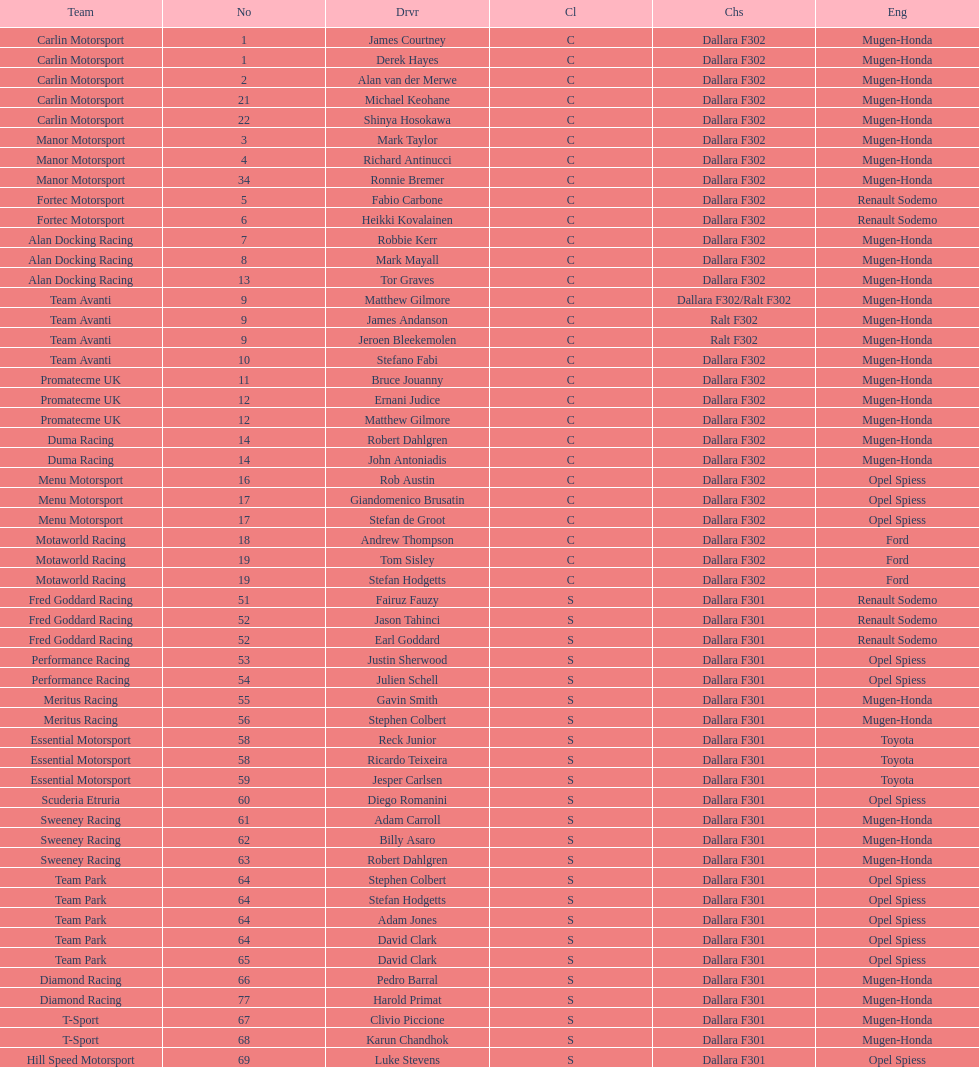Could you parse the entire table as a dict? {'header': ['Team', 'No', 'Drvr', 'Cl', 'Chs', 'Eng'], 'rows': [['Carlin Motorsport', '1', 'James Courtney', 'C', 'Dallara F302', 'Mugen-Honda'], ['Carlin Motorsport', '1', 'Derek Hayes', 'C', 'Dallara F302', 'Mugen-Honda'], ['Carlin Motorsport', '2', 'Alan van der Merwe', 'C', 'Dallara F302', 'Mugen-Honda'], ['Carlin Motorsport', '21', 'Michael Keohane', 'C', 'Dallara F302', 'Mugen-Honda'], ['Carlin Motorsport', '22', 'Shinya Hosokawa', 'C', 'Dallara F302', 'Mugen-Honda'], ['Manor Motorsport', '3', 'Mark Taylor', 'C', 'Dallara F302', 'Mugen-Honda'], ['Manor Motorsport', '4', 'Richard Antinucci', 'C', 'Dallara F302', 'Mugen-Honda'], ['Manor Motorsport', '34', 'Ronnie Bremer', 'C', 'Dallara F302', 'Mugen-Honda'], ['Fortec Motorsport', '5', 'Fabio Carbone', 'C', 'Dallara F302', 'Renault Sodemo'], ['Fortec Motorsport', '6', 'Heikki Kovalainen', 'C', 'Dallara F302', 'Renault Sodemo'], ['Alan Docking Racing', '7', 'Robbie Kerr', 'C', 'Dallara F302', 'Mugen-Honda'], ['Alan Docking Racing', '8', 'Mark Mayall', 'C', 'Dallara F302', 'Mugen-Honda'], ['Alan Docking Racing', '13', 'Tor Graves', 'C', 'Dallara F302', 'Mugen-Honda'], ['Team Avanti', '9', 'Matthew Gilmore', 'C', 'Dallara F302/Ralt F302', 'Mugen-Honda'], ['Team Avanti', '9', 'James Andanson', 'C', 'Ralt F302', 'Mugen-Honda'], ['Team Avanti', '9', 'Jeroen Bleekemolen', 'C', 'Ralt F302', 'Mugen-Honda'], ['Team Avanti', '10', 'Stefano Fabi', 'C', 'Dallara F302', 'Mugen-Honda'], ['Promatecme UK', '11', 'Bruce Jouanny', 'C', 'Dallara F302', 'Mugen-Honda'], ['Promatecme UK', '12', 'Ernani Judice', 'C', 'Dallara F302', 'Mugen-Honda'], ['Promatecme UK', '12', 'Matthew Gilmore', 'C', 'Dallara F302', 'Mugen-Honda'], ['Duma Racing', '14', 'Robert Dahlgren', 'C', 'Dallara F302', 'Mugen-Honda'], ['Duma Racing', '14', 'John Antoniadis', 'C', 'Dallara F302', 'Mugen-Honda'], ['Menu Motorsport', '16', 'Rob Austin', 'C', 'Dallara F302', 'Opel Spiess'], ['Menu Motorsport', '17', 'Giandomenico Brusatin', 'C', 'Dallara F302', 'Opel Spiess'], ['Menu Motorsport', '17', 'Stefan de Groot', 'C', 'Dallara F302', 'Opel Spiess'], ['Motaworld Racing', '18', 'Andrew Thompson', 'C', 'Dallara F302', 'Ford'], ['Motaworld Racing', '19', 'Tom Sisley', 'C', 'Dallara F302', 'Ford'], ['Motaworld Racing', '19', 'Stefan Hodgetts', 'C', 'Dallara F302', 'Ford'], ['Fred Goddard Racing', '51', 'Fairuz Fauzy', 'S', 'Dallara F301', 'Renault Sodemo'], ['Fred Goddard Racing', '52', 'Jason Tahinci', 'S', 'Dallara F301', 'Renault Sodemo'], ['Fred Goddard Racing', '52', 'Earl Goddard', 'S', 'Dallara F301', 'Renault Sodemo'], ['Performance Racing', '53', 'Justin Sherwood', 'S', 'Dallara F301', 'Opel Spiess'], ['Performance Racing', '54', 'Julien Schell', 'S', 'Dallara F301', 'Opel Spiess'], ['Meritus Racing', '55', 'Gavin Smith', 'S', 'Dallara F301', 'Mugen-Honda'], ['Meritus Racing', '56', 'Stephen Colbert', 'S', 'Dallara F301', 'Mugen-Honda'], ['Essential Motorsport', '58', 'Reck Junior', 'S', 'Dallara F301', 'Toyota'], ['Essential Motorsport', '58', 'Ricardo Teixeira', 'S', 'Dallara F301', 'Toyota'], ['Essential Motorsport', '59', 'Jesper Carlsen', 'S', 'Dallara F301', 'Toyota'], ['Scuderia Etruria', '60', 'Diego Romanini', 'S', 'Dallara F301', 'Opel Spiess'], ['Sweeney Racing', '61', 'Adam Carroll', 'S', 'Dallara F301', 'Mugen-Honda'], ['Sweeney Racing', '62', 'Billy Asaro', 'S', 'Dallara F301', 'Mugen-Honda'], ['Sweeney Racing', '63', 'Robert Dahlgren', 'S', 'Dallara F301', 'Mugen-Honda'], ['Team Park', '64', 'Stephen Colbert', 'S', 'Dallara F301', 'Opel Spiess'], ['Team Park', '64', 'Stefan Hodgetts', 'S', 'Dallara F301', 'Opel Spiess'], ['Team Park', '64', 'Adam Jones', 'S', 'Dallara F301', 'Opel Spiess'], ['Team Park', '64', 'David Clark', 'S', 'Dallara F301', 'Opel Spiess'], ['Team Park', '65', 'David Clark', 'S', 'Dallara F301', 'Opel Spiess'], ['Diamond Racing', '66', 'Pedro Barral', 'S', 'Dallara F301', 'Mugen-Honda'], ['Diamond Racing', '77', 'Harold Primat', 'S', 'Dallara F301', 'Mugen-Honda'], ['T-Sport', '67', 'Clivio Piccione', 'S', 'Dallara F301', 'Mugen-Honda'], ['T-Sport', '68', 'Karun Chandhok', 'S', 'Dallara F301', 'Mugen-Honda'], ['Hill Speed Motorsport', '69', 'Luke Stevens', 'S', 'Dallara F301', 'Opel Spiess']]} Who had more drivers, team avanti or motaworld racing? Team Avanti. 